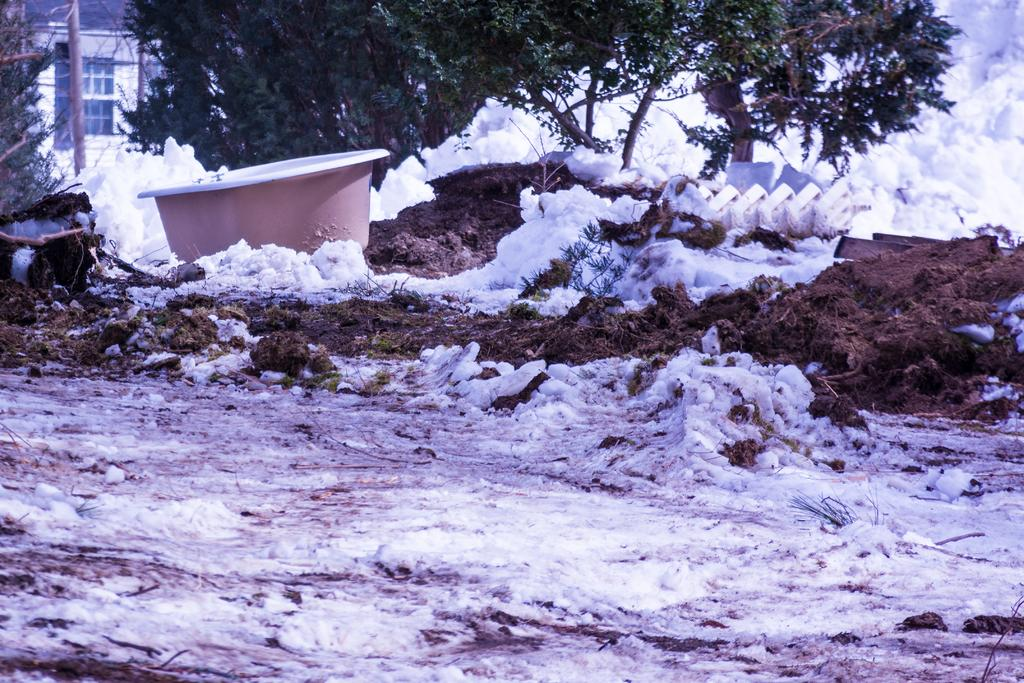What can be seen at the bottom of the image? There is snow and sand at the bottom of the image. What is located on the left side of the image? There is a tub on the left side of the image. What is visible in the background of the image? There is a house, trees, snow, and some unspecified objects in the background of the image. What type of wrench is being used to measure the sugar content in the image? There is no wrench or sugar present in the image. Is the scene taking place during the night in the image? The image does not provide any information about the time of day, so it cannot be determined if it is night or not. 